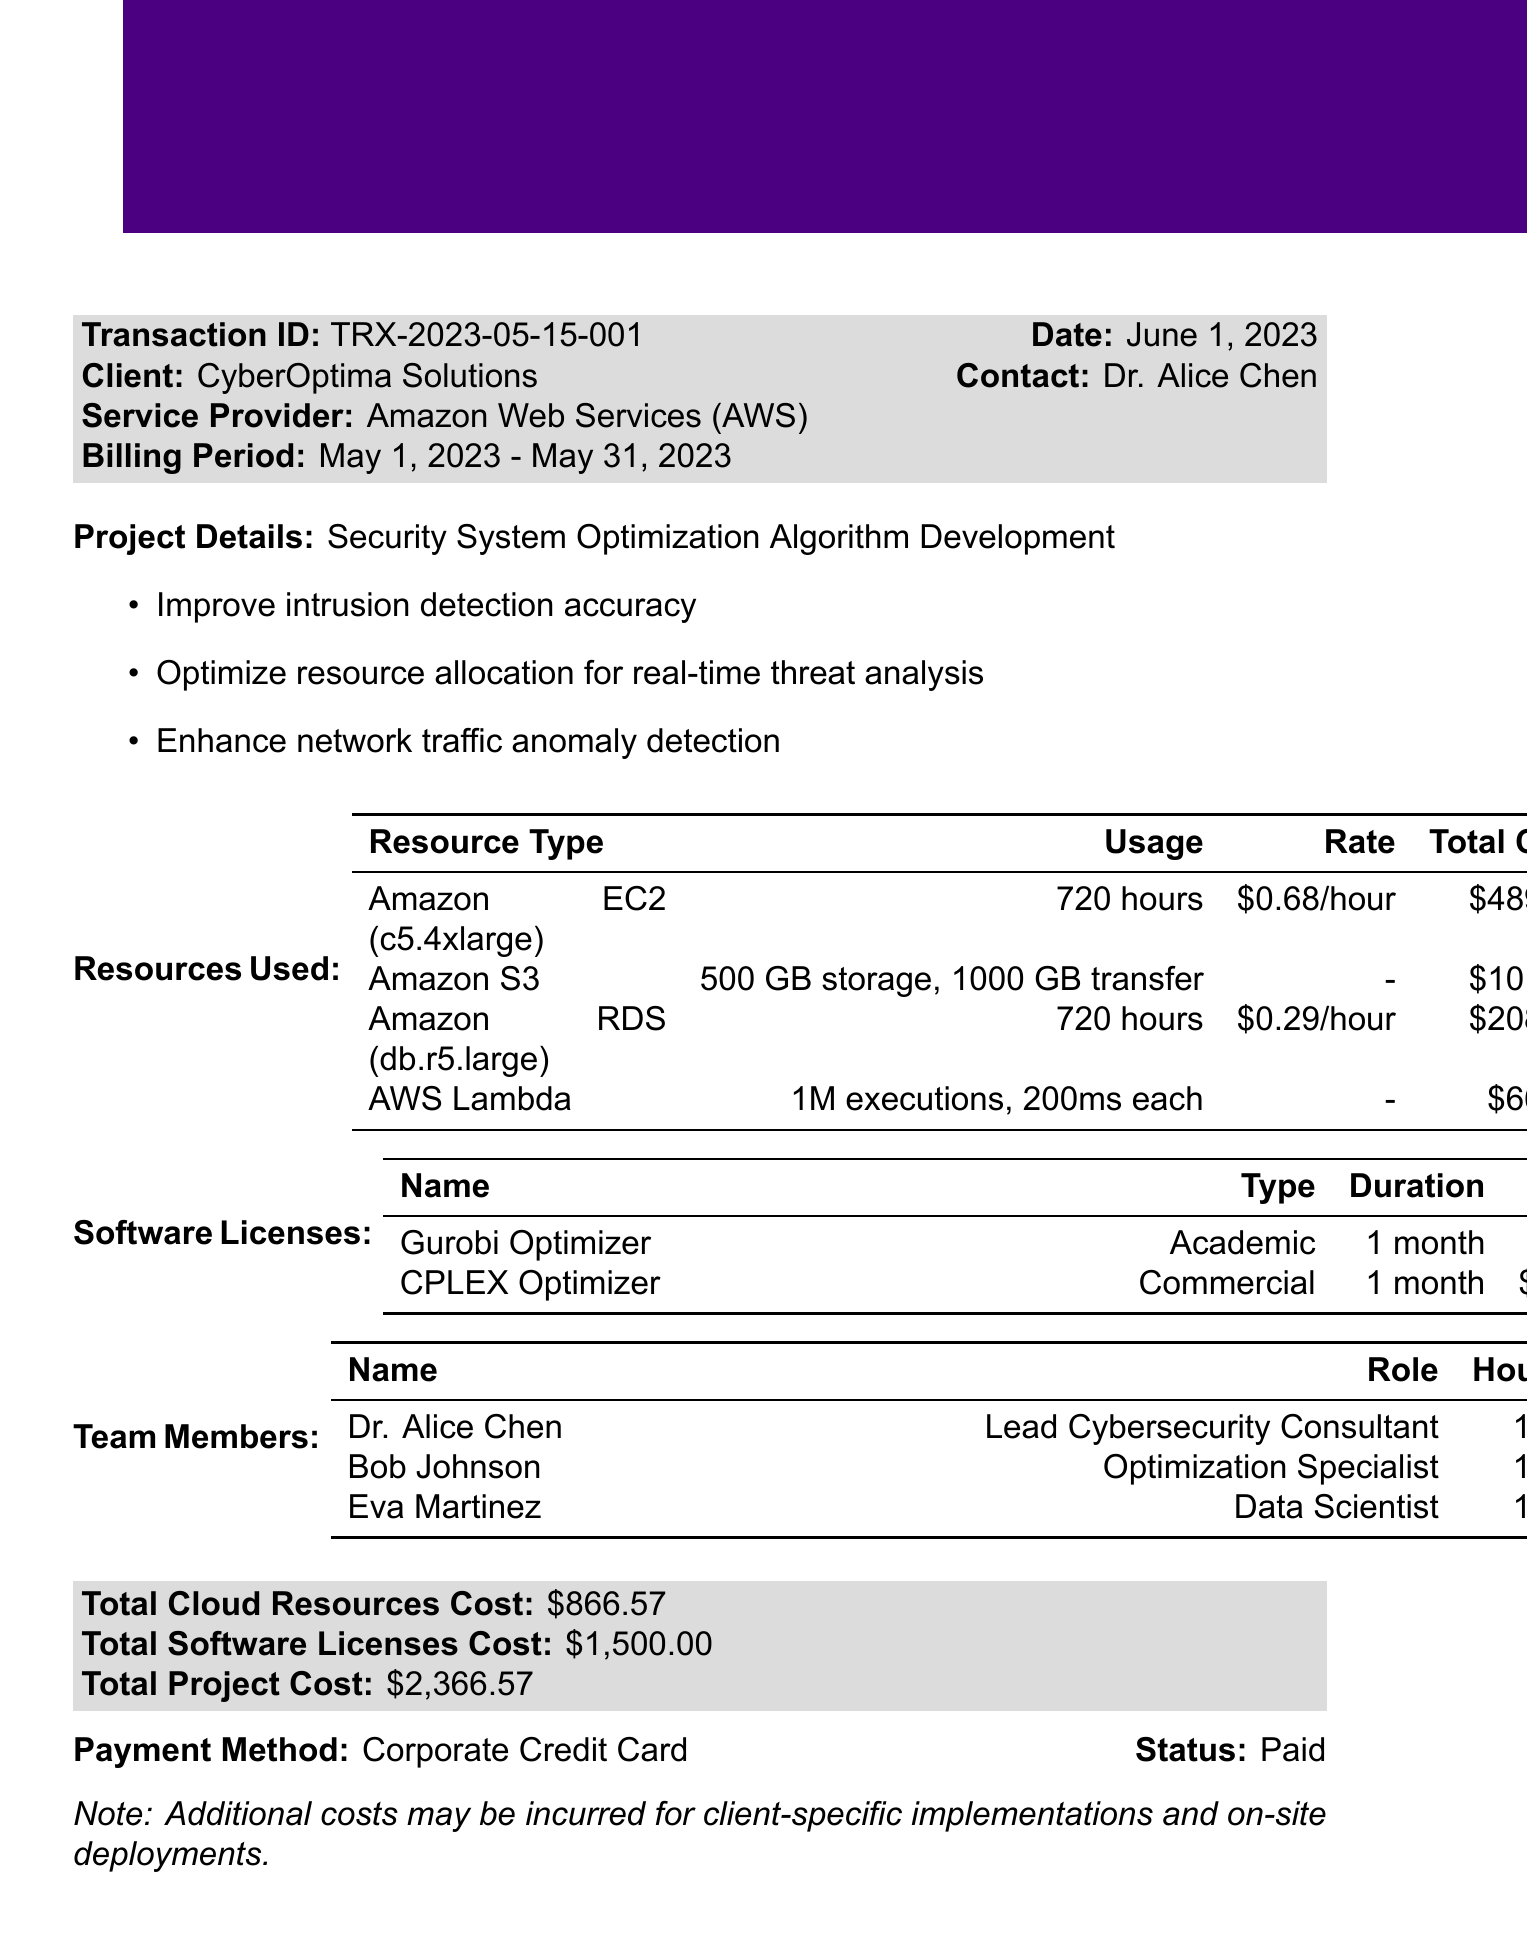What is the transaction ID? The transaction ID is specifically mentioned in the document as TRX-2023-05-15-001.
Answer: TRX-2023-05-15-001 Who is the client contact? The document states Dr. Alice Chen as the client contact for CyberOptima Solutions.
Answer: Dr. Alice Chen What is the total cost for cloud resources? The total cloud resources cost is clearly noted in the document as $866.57.
Answer: $866.57 How many hours did the Lead Cybersecurity Consultant work? The document indicates that Dr. Alice Chen worked 160 hours on the project.
Answer: 160 What software license has no cost? The document lists Gurobi Optimizer as the software license with a cost of $0.
Answer: Gurobi Optimizer What resource type was used for storage and data transfer? The document mentions Amazon S3 as the resource type used for both storage and data transfer.
Answer: Amazon S3 What is the billing period for the transaction? The billing period provided in the document is from May 1, 2023 to May 31, 2023.
Answer: May 1, 2023 - May 31, 2023 What is the payment status of the transaction? The document specifies that the payment status is "Paid."
Answer: Paid Name one objective of the project. One objective mentioned is "Improve intrusion detection accuracy" for the project.
Answer: Improve intrusion detection accuracy 